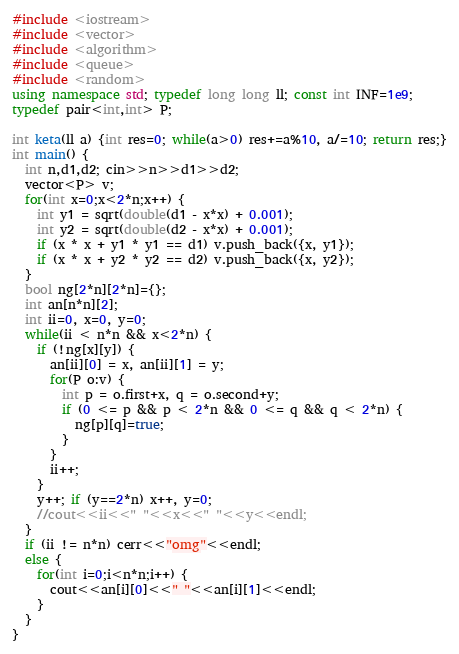<code> <loc_0><loc_0><loc_500><loc_500><_C++_>#include <iostream>
#include <vector>
#include <algorithm>
#include <queue>
#include <random>
using namespace std; typedef long long ll; const int INF=1e9;
typedef pair<int,int> P;

int keta(ll a) {int res=0; while(a>0) res+=a%10, a/=10; return res;}
int main() {
  int n,d1,d2; cin>>n>>d1>>d2;
  vector<P> v;
  for(int x=0;x<2*n;x++) {
    int y1 = sqrt(double(d1 - x*x) + 0.001);
    int y2 = sqrt(double(d2 - x*x) + 0.001);
    if (x * x + y1 * y1 == d1) v.push_back({x, y1});
    if (x * x + y2 * y2 == d2) v.push_back({x, y2});
  }
  bool ng[2*n][2*n]={};
  int an[n*n][2];
  int ii=0, x=0, y=0;
  while(ii < n*n && x<2*n) {
    if (!ng[x][y]) {
      an[ii][0] = x, an[ii][1] = y;
      for(P o:v) {
        int p = o.first+x, q = o.second+y;
        if (0 <= p && p < 2*n && 0 <= q && q < 2*n) {
          ng[p][q]=true;
        }
      }
      ii++;
    }
    y++; if (y==2*n) x++, y=0;
    //cout<<ii<<" "<<x<<" "<<y<<endl;
  }
  if (ii != n*n) cerr<<"omg"<<endl;
  else {
    for(int i=0;i<n*n;i++) {
      cout<<an[i][0]<<" "<<an[i][1]<<endl;
    }
  }
}</code> 